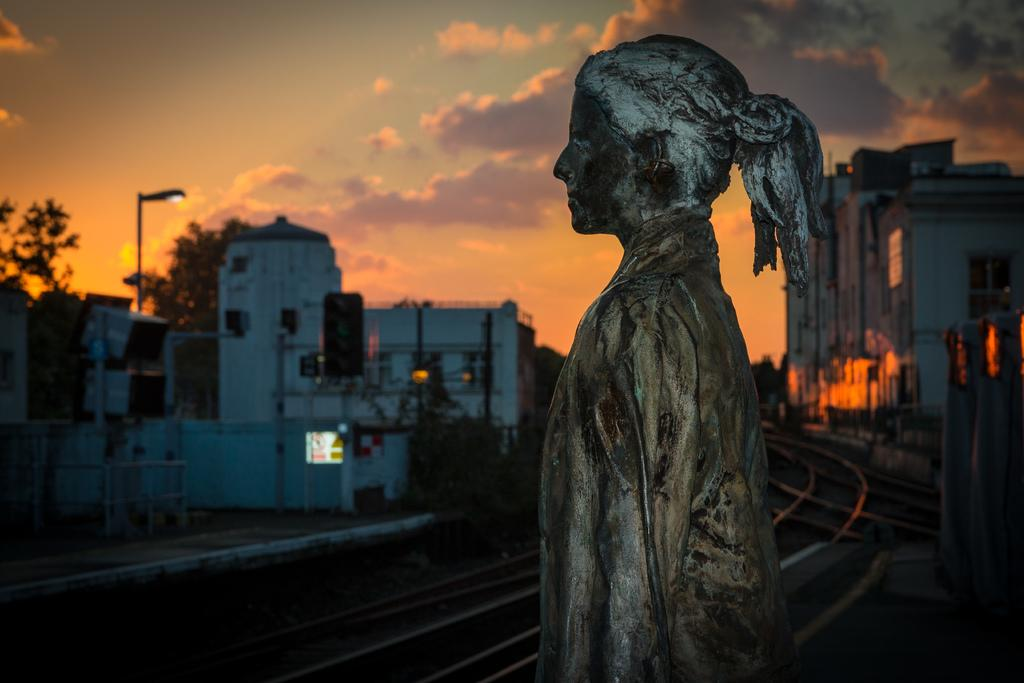What is the main subject in the image? There is a statue in the image. What can be seen in the background of the image? There are railway tracks, buildings, trees, and a street light pole in the background of the image. What is the condition of the sky in the image? The sky is clear in the image. What type of cabbage is growing on the statue in the image? There is no cabbage present on the statue in the image; it is a statue and not a garden. What observation can be made about the statue's relationship with the railway tracks in the image? The image does not provide any information about the statue's relationship with the railway tracks; it only shows that they are both present in the same scene. 